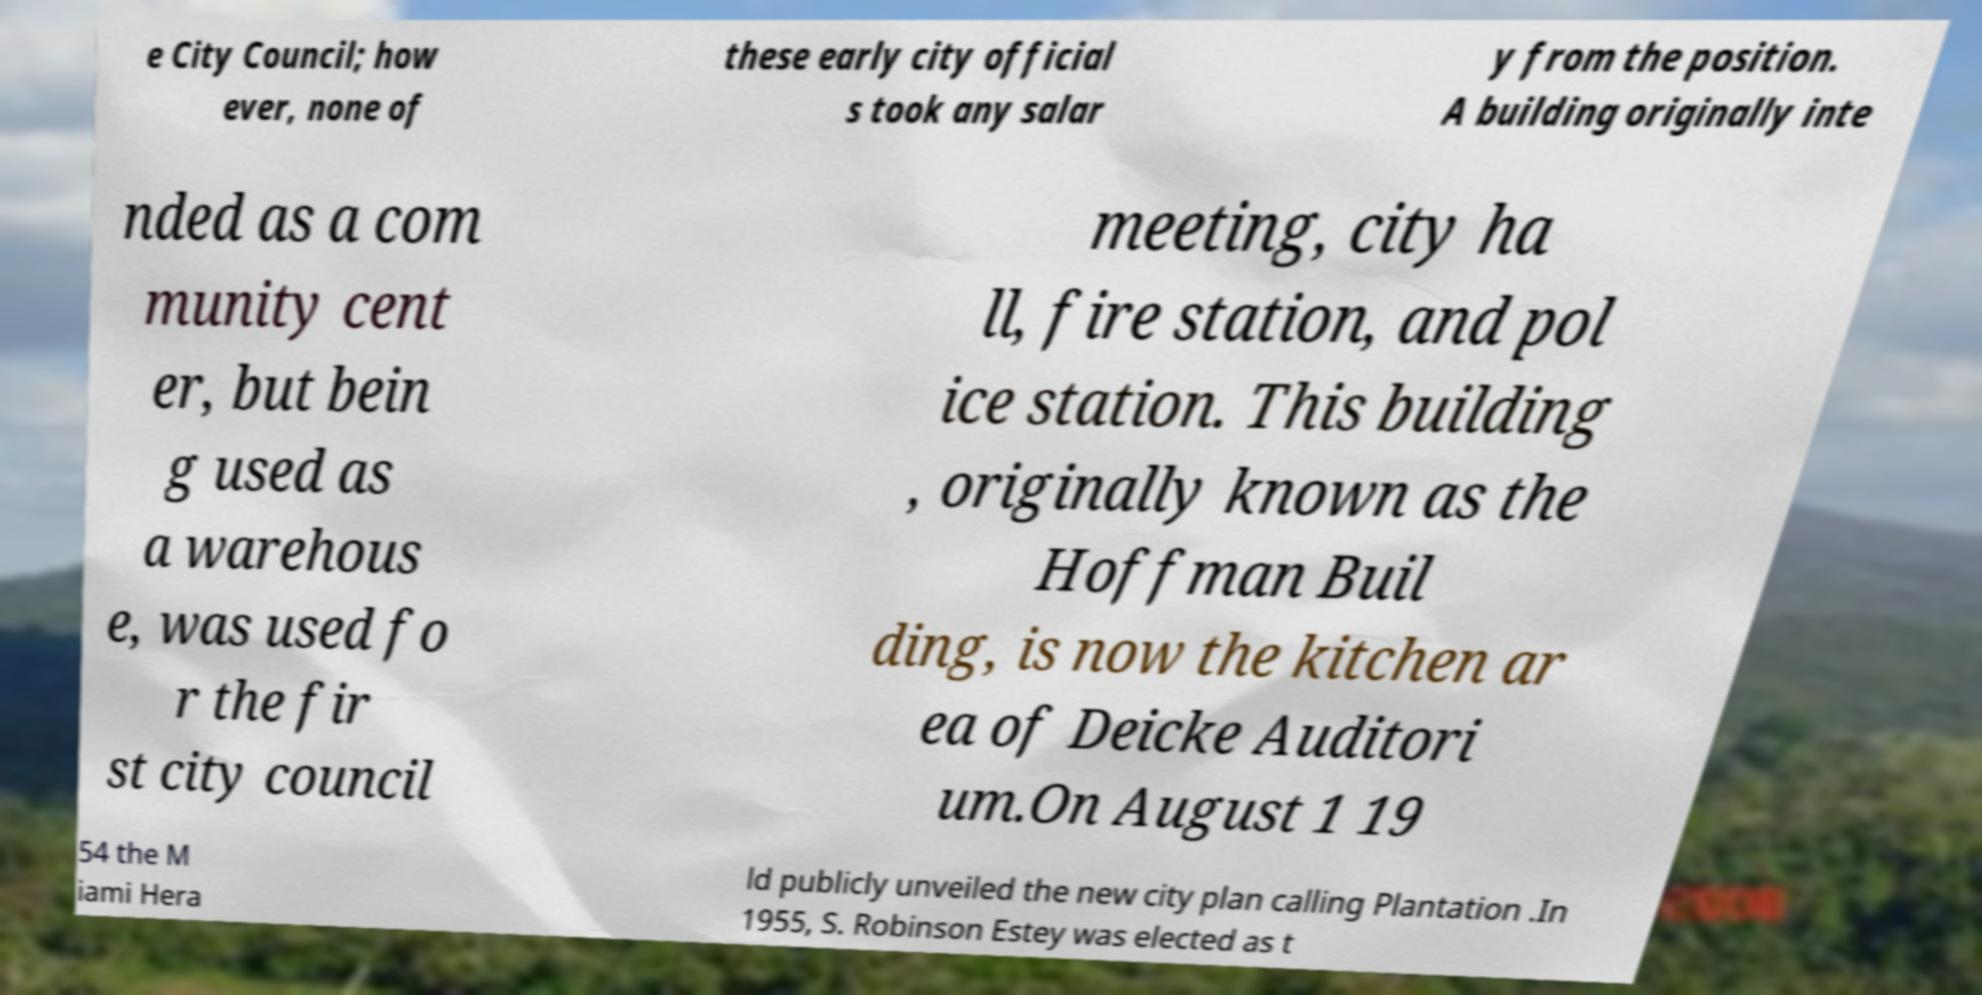What messages or text are displayed in this image? I need them in a readable, typed format. e City Council; how ever, none of these early city official s took any salar y from the position. A building originally inte nded as a com munity cent er, but bein g used as a warehous e, was used fo r the fir st city council meeting, city ha ll, fire station, and pol ice station. This building , originally known as the Hoffman Buil ding, is now the kitchen ar ea of Deicke Auditori um.On August 1 19 54 the M iami Hera ld publicly unveiled the new city plan calling Plantation .In 1955, S. Robinson Estey was elected as t 